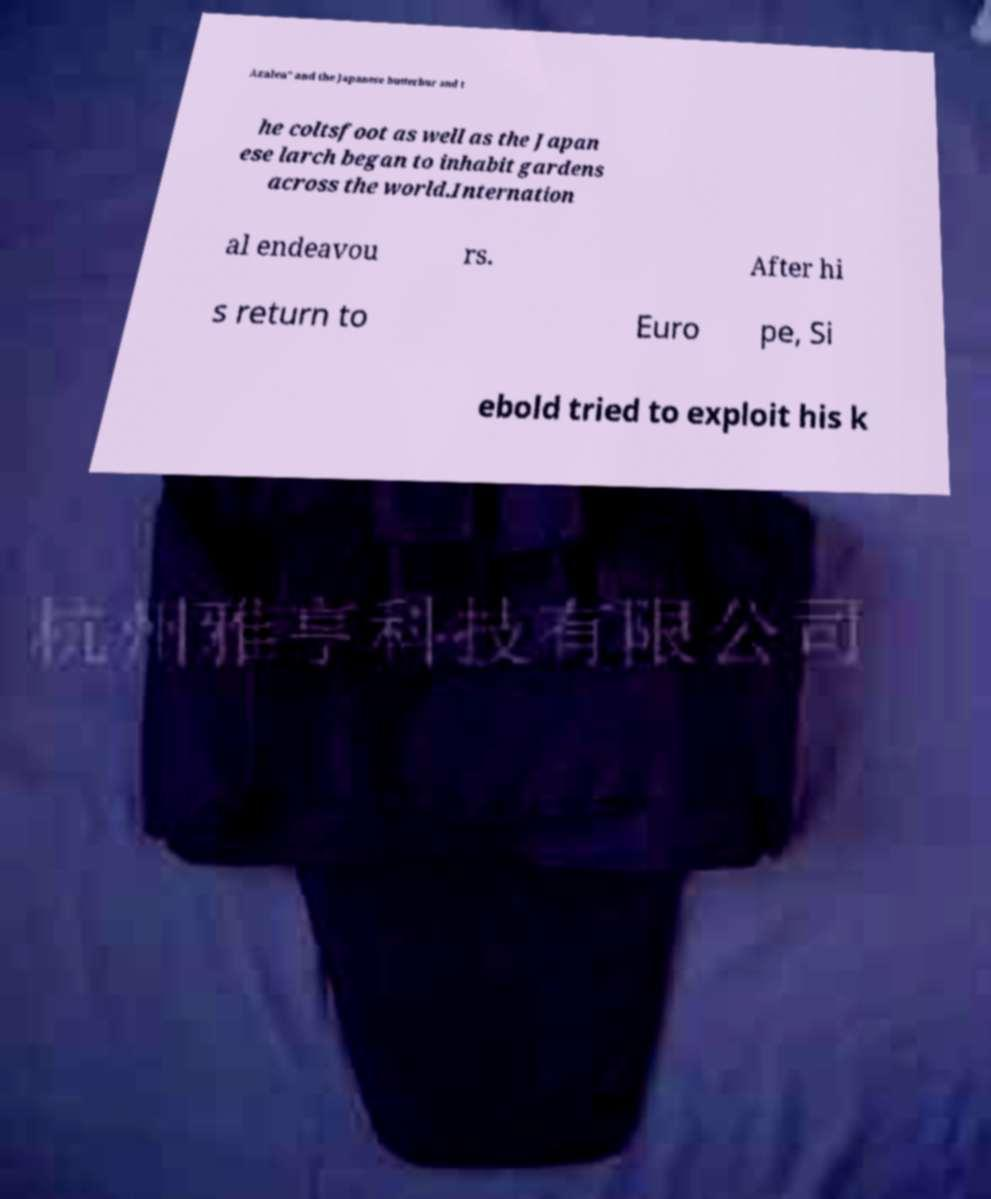What messages or text are displayed in this image? I need them in a readable, typed format. Azalea" and the Japanese butterbur and t he coltsfoot as well as the Japan ese larch began to inhabit gardens across the world.Internation al endeavou rs. After hi s return to Euro pe, Si ebold tried to exploit his k 